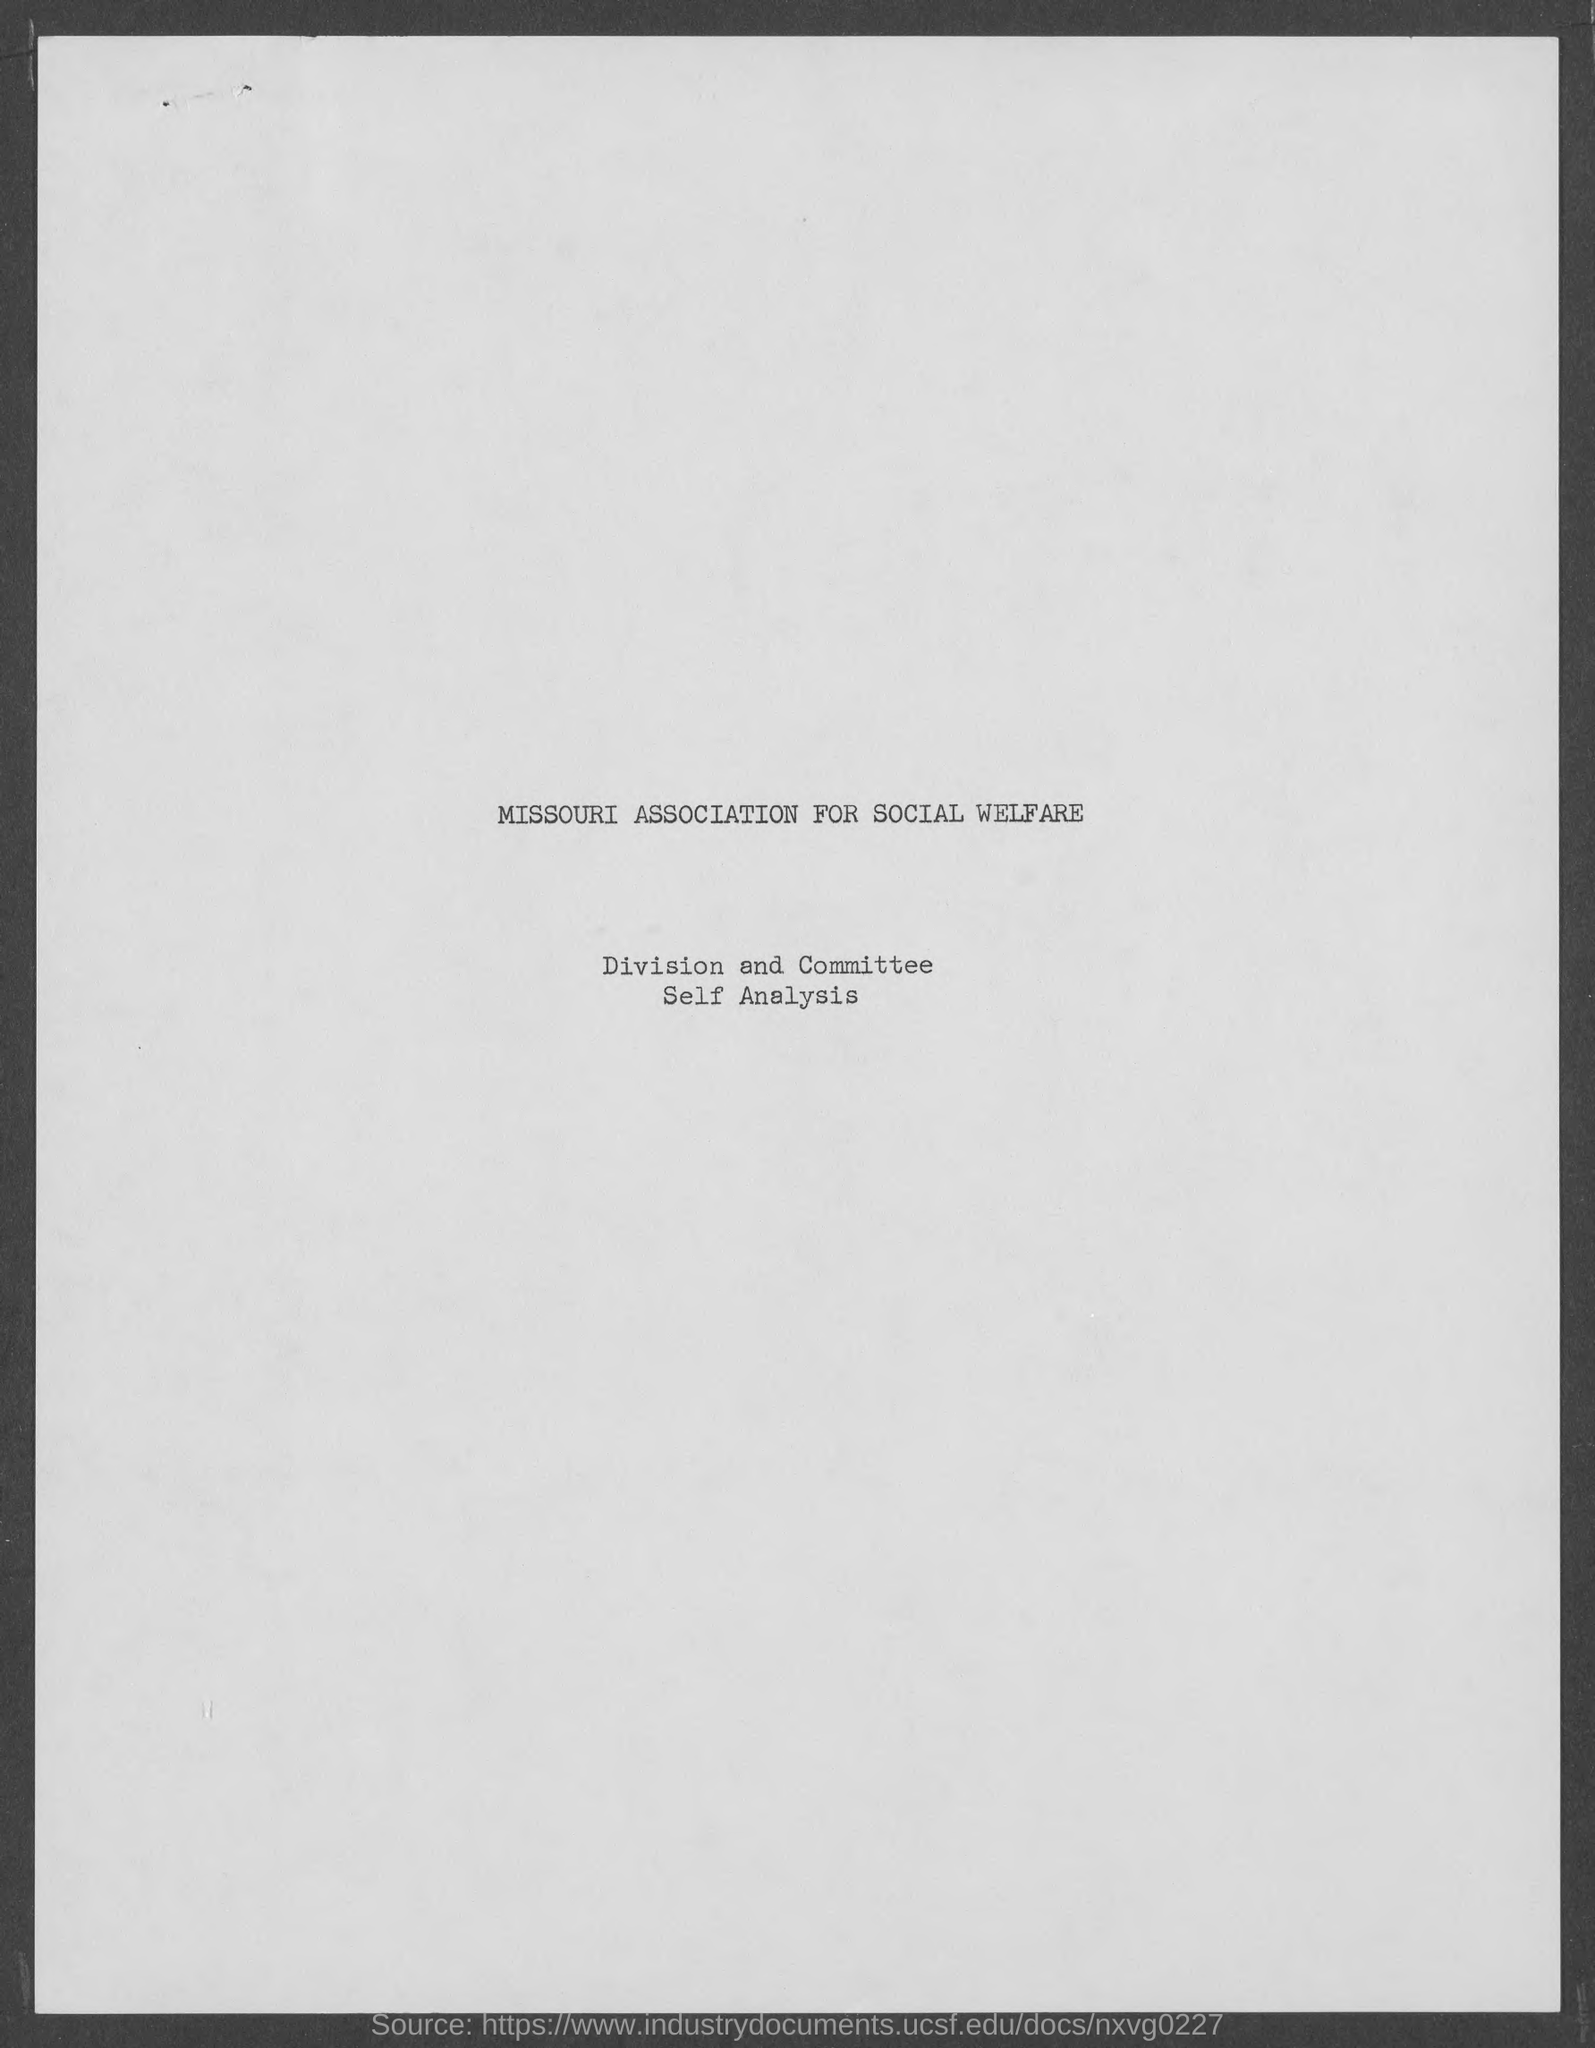Give some essential details in this illustration. The document mentions the Missouri Association for Social Welfare. 